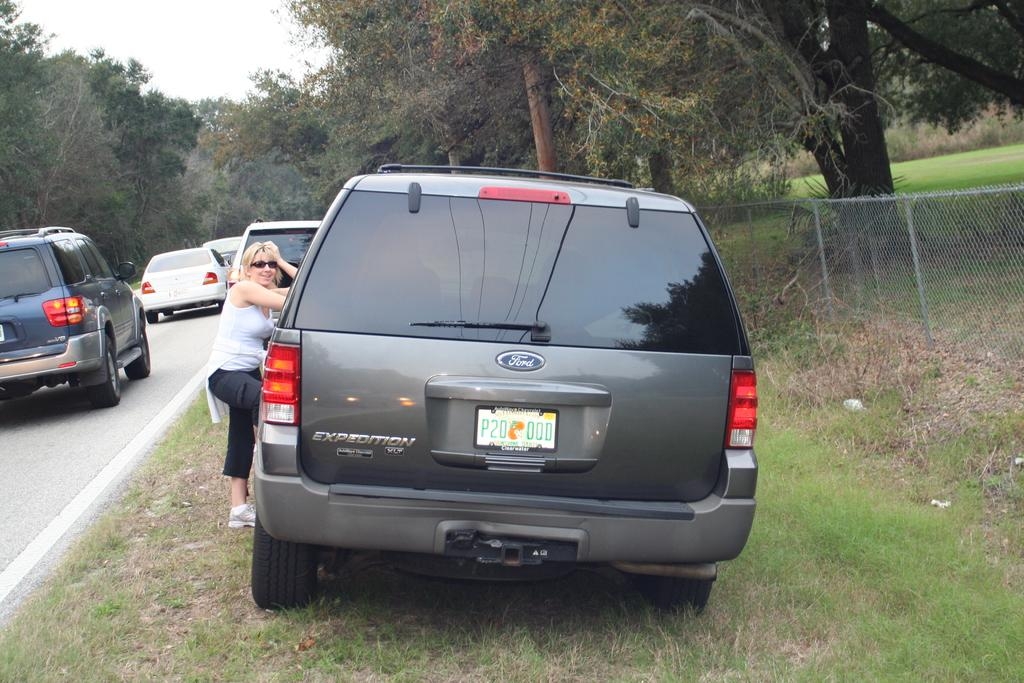<image>
Share a concise interpretation of the image provided. A woman sits at the driver door of a grey ford car. 